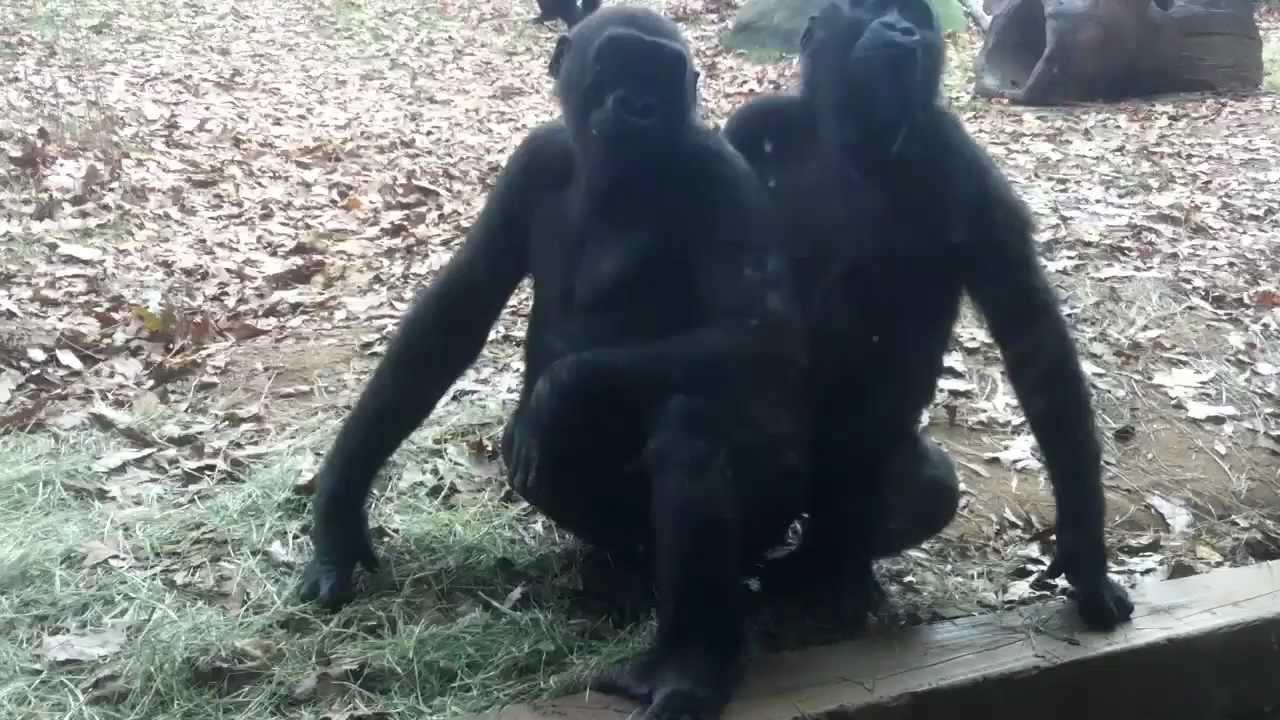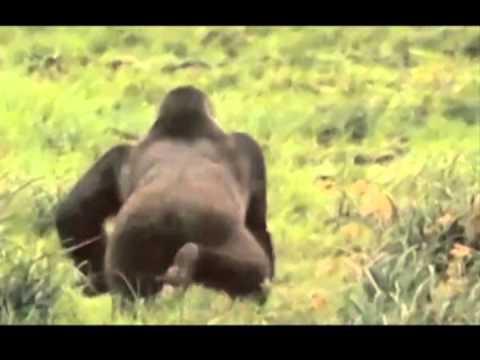The first image is the image on the left, the second image is the image on the right. Considering the images on both sides, is "There is a single male ape not looking at the camera." valid? Answer yes or no. Yes. 